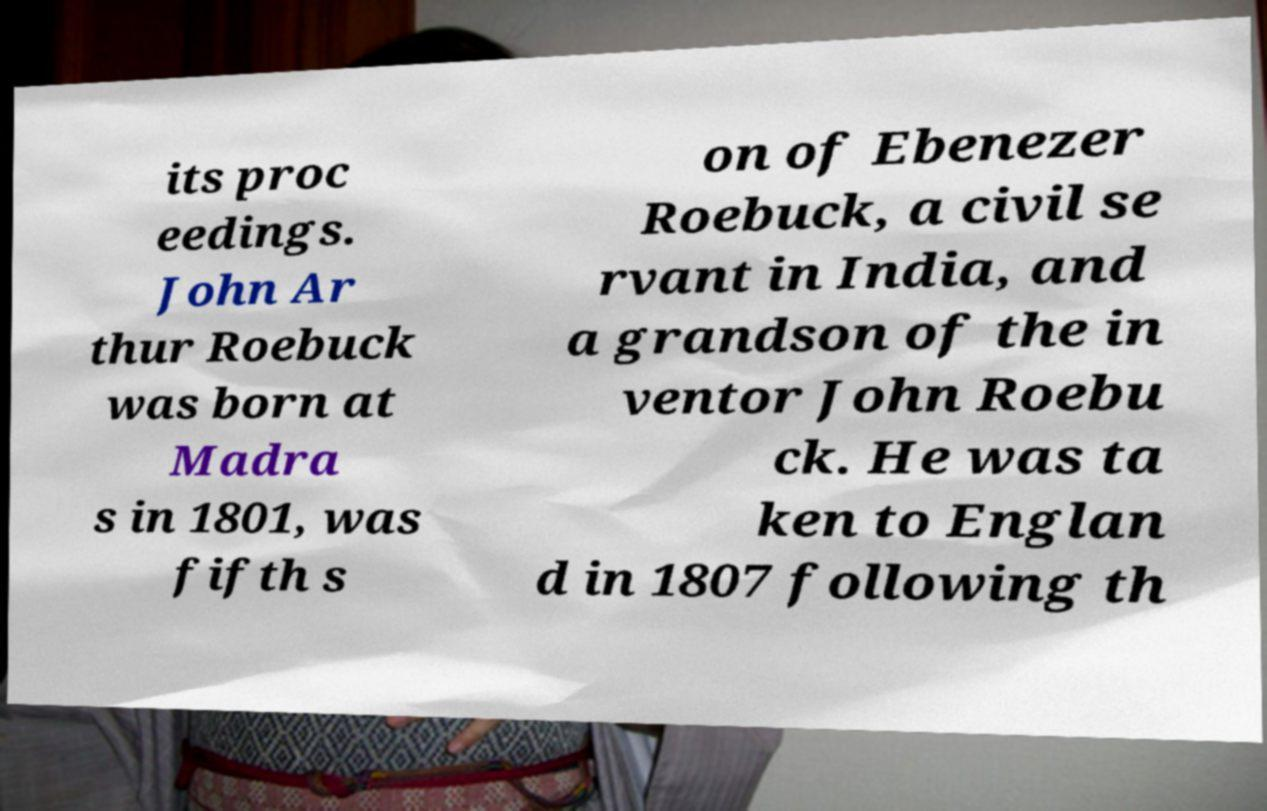I need the written content from this picture converted into text. Can you do that? its proc eedings. John Ar thur Roebuck was born at Madra s in 1801, was fifth s on of Ebenezer Roebuck, a civil se rvant in India, and a grandson of the in ventor John Roebu ck. He was ta ken to Englan d in 1807 following th 